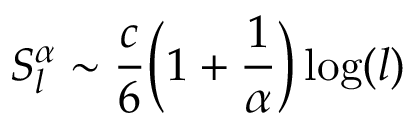<formula> <loc_0><loc_0><loc_500><loc_500>S _ { l } ^ { \alpha } \sim \frac { c } { 6 } \left ( 1 + \frac { 1 } { \alpha } \right ) \log ( l )</formula> 